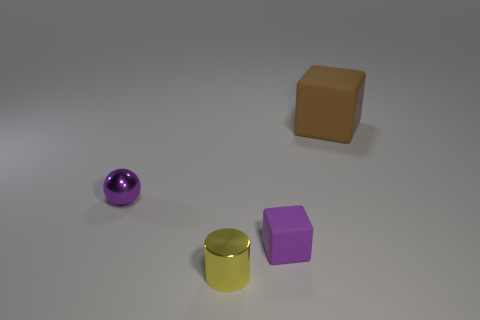Is the number of brown rubber things that are in front of the shiny cylinder less than the number of tiny purple blocks?
Keep it short and to the point. Yes. What is the color of the matte cube in front of the tiny purple metallic thing?
Your answer should be very brief. Purple. There is a tiny matte thing; what shape is it?
Offer a terse response. Cube. There is a cube that is behind the block to the left of the large brown rubber thing; are there any cylinders that are left of it?
Offer a terse response. Yes. There is a block right of the matte cube that is in front of the cube right of the purple cube; what is its color?
Ensure brevity in your answer.  Brown. What material is the small purple object that is the same shape as the large brown rubber thing?
Your response must be concise. Rubber. There is a metallic object in front of the purple matte object that is in front of the ball; what size is it?
Your response must be concise. Small. What is the purple cube in front of the big brown matte thing made of?
Provide a succinct answer. Rubber. What size is the thing that is made of the same material as the purple cube?
Offer a terse response. Large. What number of other brown matte things have the same shape as the small matte thing?
Keep it short and to the point. 1. 